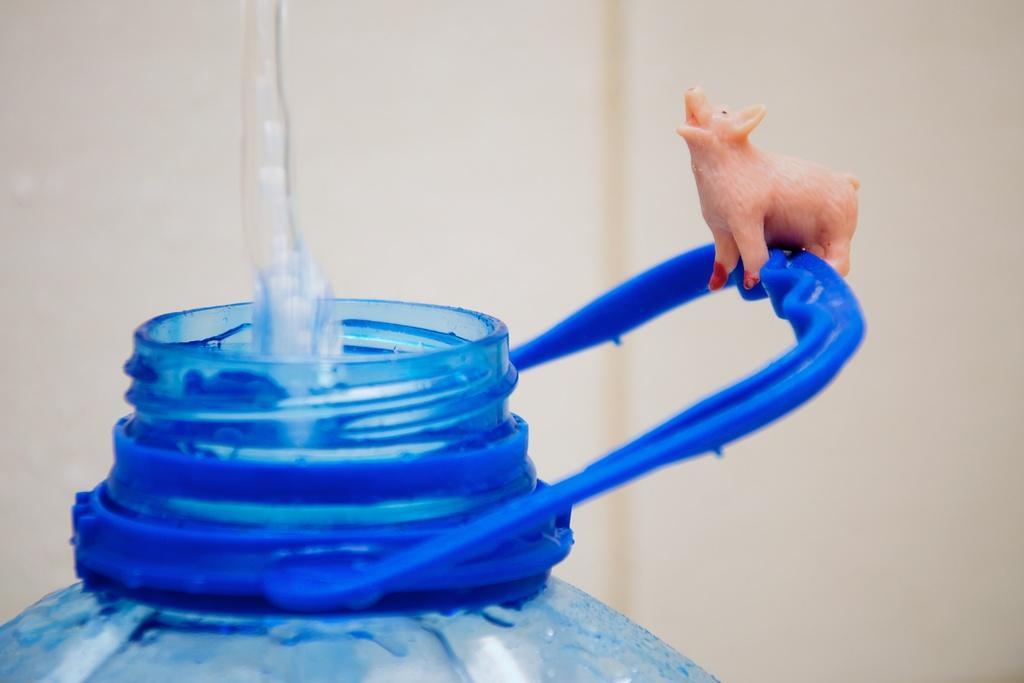In one or two sentences, can you explain what this image depicts? In this picture there is a part of the bottle and there is a toy which is placed over the handle of the bottle and someone is pouring the water into it, the bottle is blue in color. 